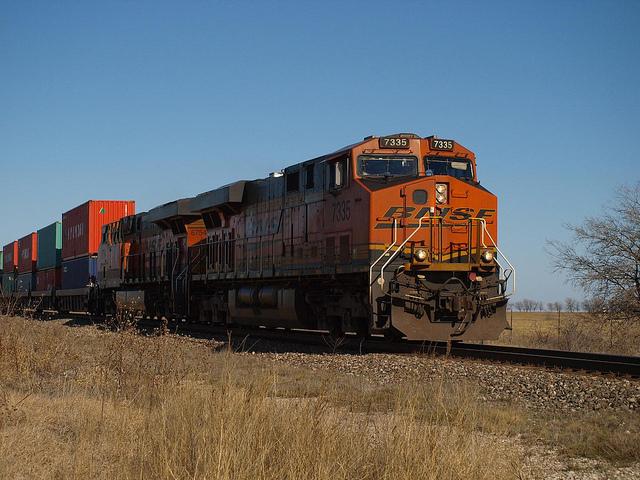Does the sky look threatening?
Answer briefly. No. What are the two main colors of the train engine?
Be succinct. Orange and black. Is it a cloudy day?
Give a very brief answer. No. Are there planes in the sky?
Quick response, please. No. What is covering the ground?
Keep it brief. Grass. What number is on the train?
Give a very brief answer. 7335. Is the train going left or right?
Keep it brief. Right. How many lights are on the front of the train?
Short answer required. 4. What numbers appear on the side of the train?
Write a very short answer. 7335. Are there clouds visible?
Concise answer only. No. Is there a light pole in this picture?
Be succinct. No. There are flowers in the picture?
Answer briefly. No. Is the train currently in motion?
Short answer required. Yes. Is this a steam train?
Answer briefly. No. How many train tracks are there?
Quick response, please. 1. What are the letters on the train engine?
Quick response, please. Bnse. What color is the train?
Be succinct. Orange. Is it wintertime?
Short answer required. No. How many trains are shown?
Write a very short answer. 1. What color is the grass?
Quick response, please. Brown. Is this a passenger train?
Write a very short answer. No. Is there more than one track?
Short answer required. No. 